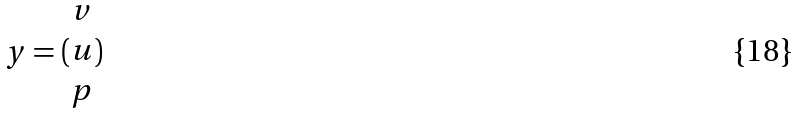Convert formula to latex. <formula><loc_0><loc_0><loc_500><loc_500>y = ( \begin{matrix} v \\ u \\ p \end{matrix} )</formula> 